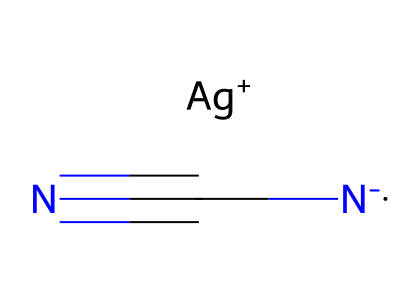how many atoms are in this compound? The SMILES representation depicts one silver atom (Ag) and three nitrogen atoms (two from the [N-] and one from the C#N), totaling four atoms.
Answer: four what type of ligand is represented in this structure? The [N-] indicates that the nitrogen is acting as a negatively charged ligand, which often forms coordinate bonds with metal centers such as silver.
Answer: negatively charged ligand what is the oxidation state of silver in this coordination compound? In this compound, silver (Ag) has a +1 charge (notated as [Ag+]), indicating it is in the +1 oxidation state.
Answer: +1 how many coordination sites does silver occupy in this compound? The silver ion (Ag+) typically forms two coordination sites by accepting electron pairs from two ligands; in this case, it's coordinated by two nitrogen atoms.
Answer: two what type of bonding is primarily involved in the interaction between silver and the ligands? The interaction between silver and the negatively charged nitrogen ligands involves coordinate covalent bonding where the ligands donate electron pairs to the metal ion.
Answer: coordinate covalent how does the presence of the cyanide group affect the compound's properties? The cyanide group (C#N) is highly electronegative and stabilizes the complex while also enhancing its sensitivity in photographic applications, resulting in distinct light response properties.
Answer: enhances sensitivity 